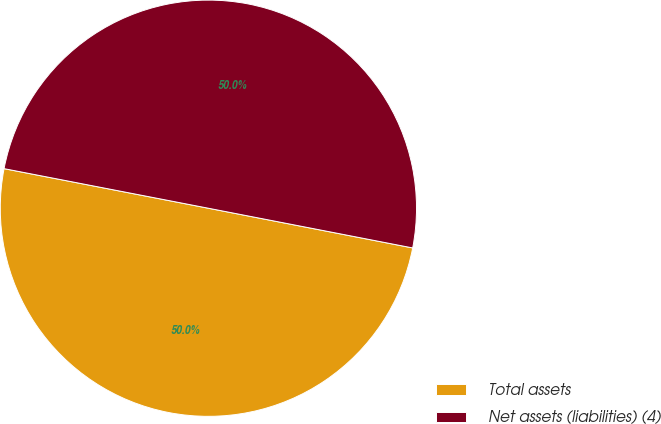Convert chart to OTSL. <chart><loc_0><loc_0><loc_500><loc_500><pie_chart><fcel>Total assets<fcel>Net assets (liabilities) (4)<nl><fcel>49.99%<fcel>50.01%<nl></chart> 